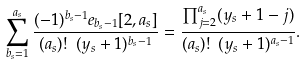Convert formula to latex. <formula><loc_0><loc_0><loc_500><loc_500>\sum _ { b _ { s } = 1 } ^ { a _ { s } } \frac { ( - 1 ) ^ { b _ { s } - 1 } e _ { b _ { s } - 1 } [ 2 , a _ { s } ] } { ( a _ { s } ) ! \ ( y _ { s } + 1 ) ^ { b _ { s } - 1 } } = \frac { \prod _ { j = 2 } ^ { a _ { s } } ( y _ { s } + 1 - j ) } { ( a _ { s } ) ! \ ( y _ { s } + 1 ) ^ { a _ { s } - 1 } } .</formula> 